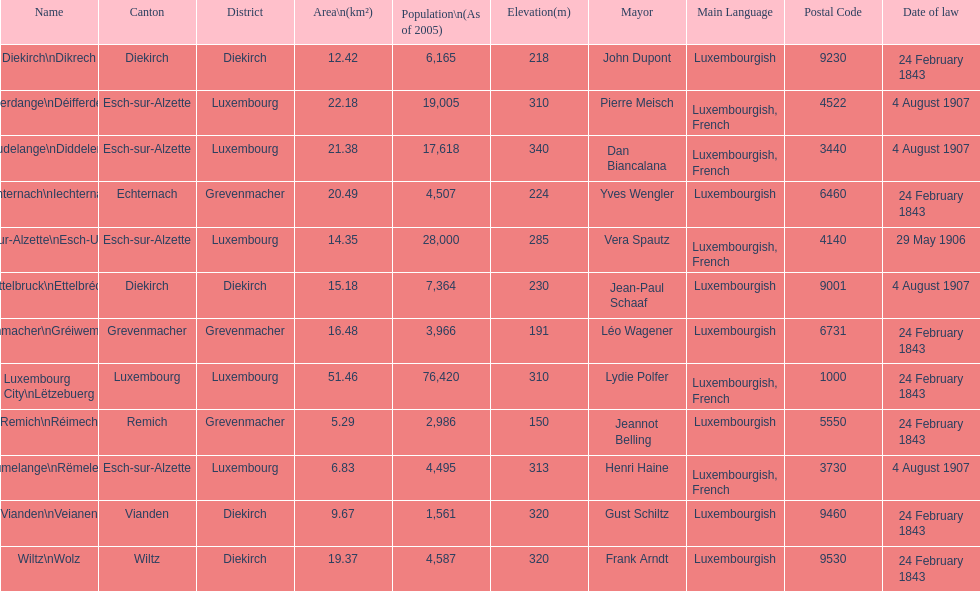How many diekirch districts also have diekirch as their canton? 2. 